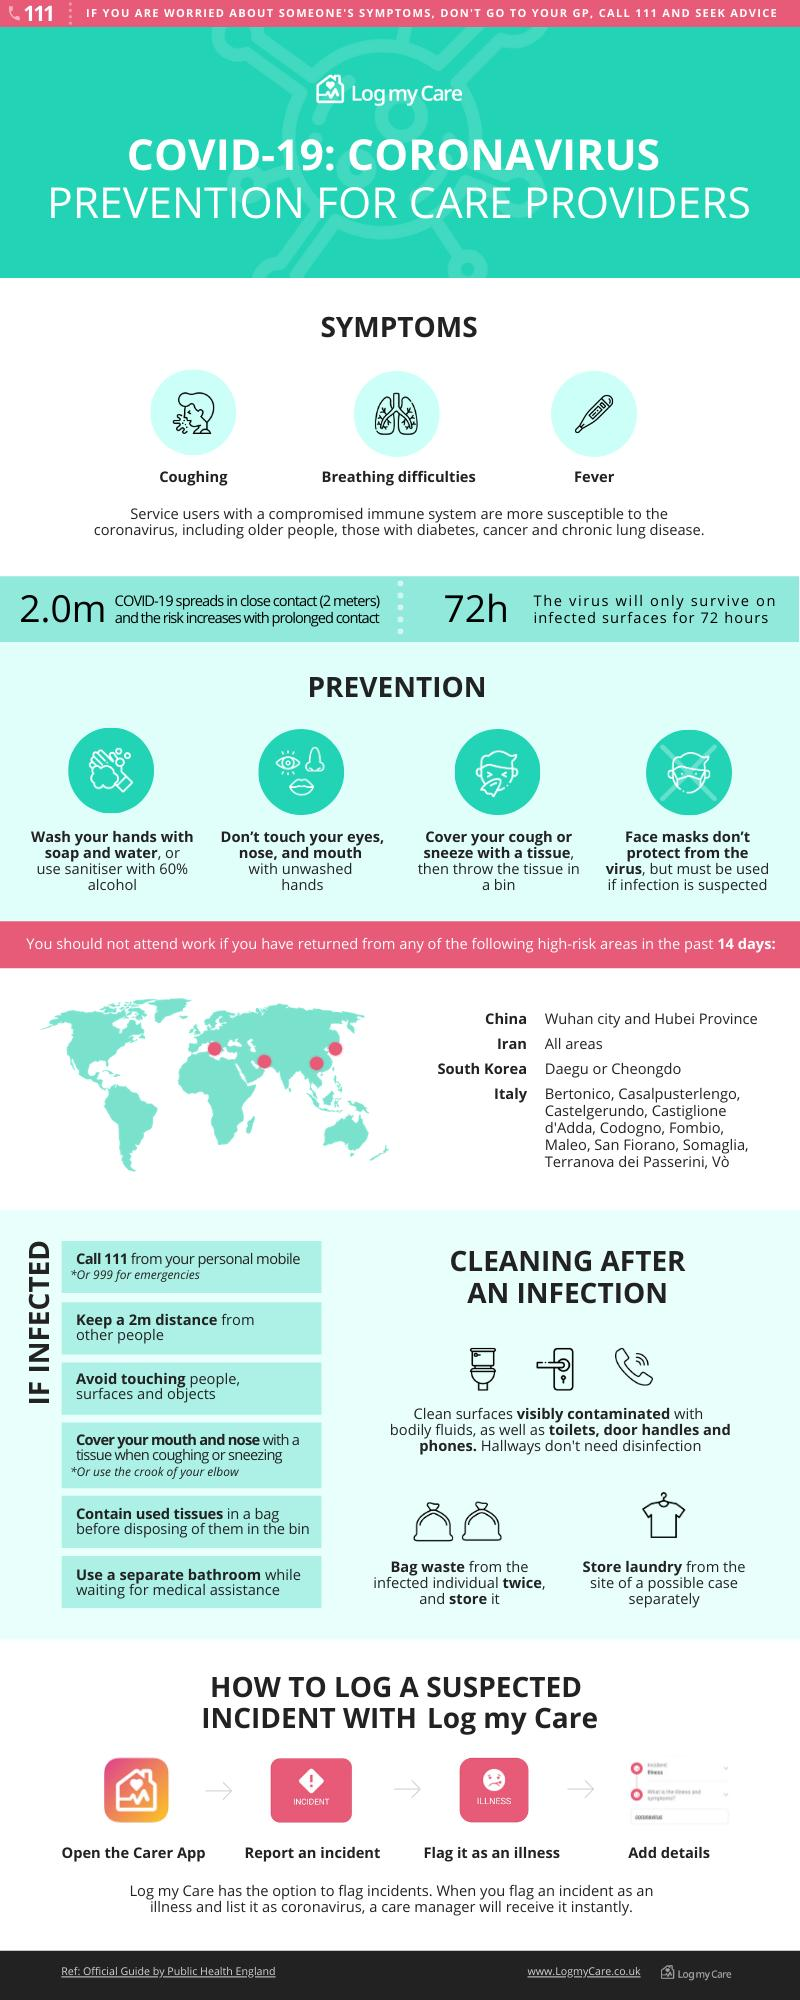Draw attention to some important aspects in this diagram. COVID-19 may present with symptoms other than fever and coughing, such as breathing difficulties. The Covid-19 virus can remain infectious on surfaces for up to 72 hours. It is considered to be the high-risk area, whether it is Daegu or Cheongdo, in South Korea. It is essential to maintain a minimum safe distance of two meters between oneself and others to effectively control the spread of the COVID-19 virus. 